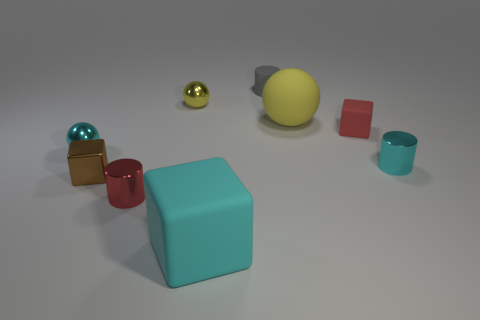How many objects are there in the image? There are seven objects in total, including a variety of cubes and spheres in different sizes and colors. 